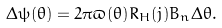Convert formula to latex. <formula><loc_0><loc_0><loc_500><loc_500>\Delta \psi ( \theta ) = 2 \pi \varpi ( \theta ) R _ { H } ( j ) B _ { n } \Delta \theta .</formula> 